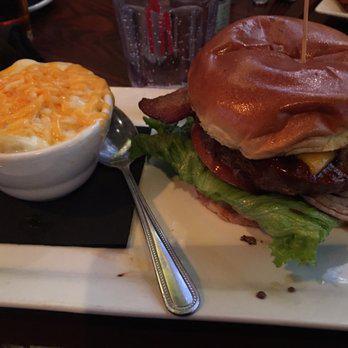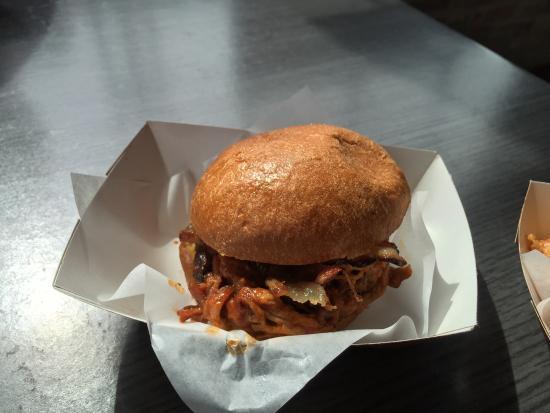The first image is the image on the left, the second image is the image on the right. For the images displayed, is the sentence "An image shows a burger next to slender french fries on a white paper in a container." factually correct? Answer yes or no. No. The first image is the image on the left, the second image is the image on the right. For the images displayed, is the sentence "There are two burgers sitting on paper." factually correct? Answer yes or no. No. 